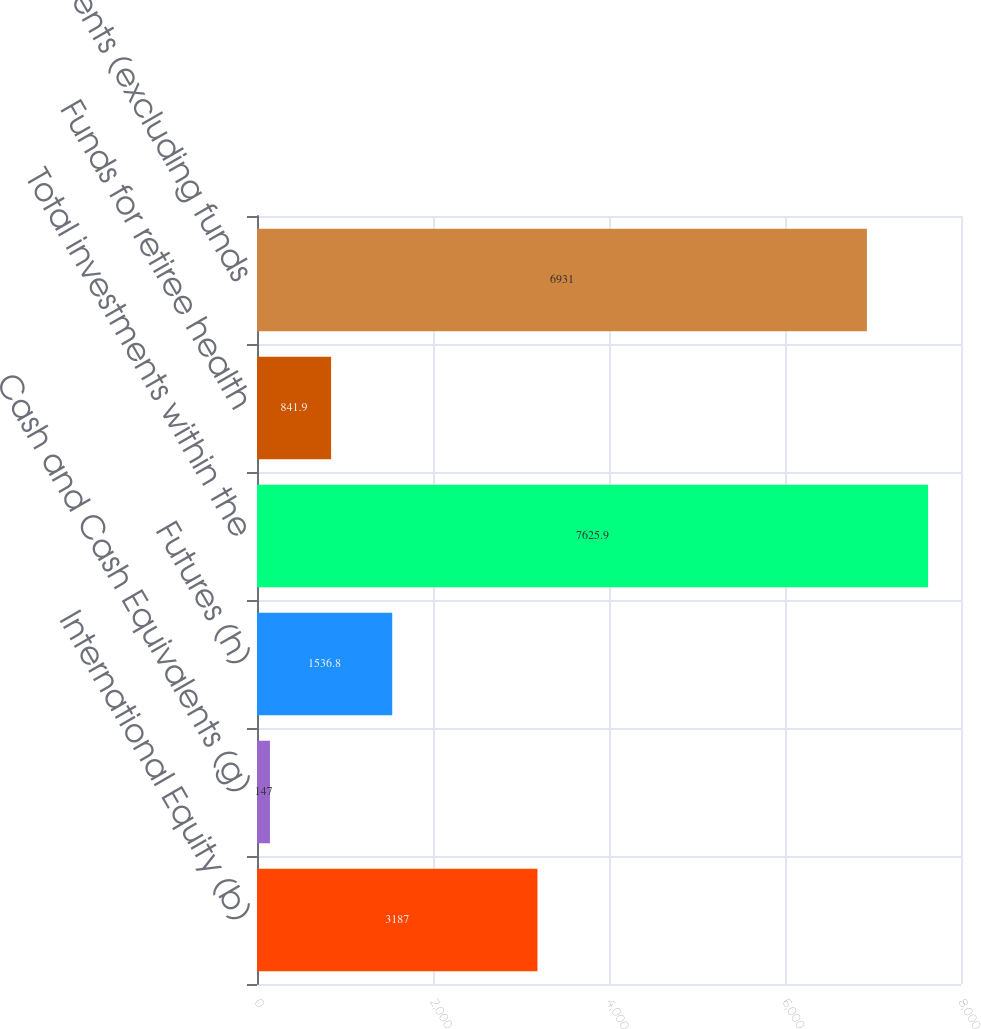<chart> <loc_0><loc_0><loc_500><loc_500><bar_chart><fcel>International Equity (b)<fcel>Cash and Cash Equivalents (g)<fcel>Futures (h)<fcel>Total investments within the<fcel>Funds for retiree health<fcel>Investments (excluding funds<nl><fcel>3187<fcel>147<fcel>1536.8<fcel>7625.9<fcel>841.9<fcel>6931<nl></chart> 